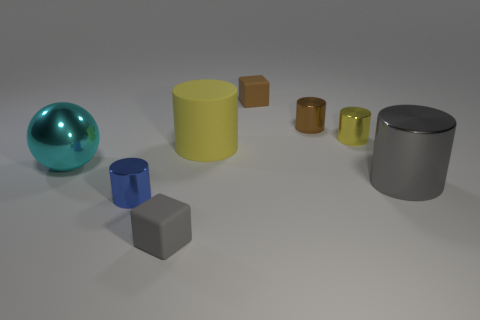Subtract all green balls. How many yellow cylinders are left? 2 Subtract all gray cylinders. How many cylinders are left? 4 Add 1 small brown cylinders. How many objects exist? 9 Subtract all blue cylinders. How many cylinders are left? 4 Subtract all cylinders. How many objects are left? 3 Subtract all blue cylinders. Subtract all green spheres. How many cylinders are left? 4 Add 5 large gray metal cylinders. How many large gray metal cylinders exist? 6 Subtract 1 blue cylinders. How many objects are left? 7 Subtract all big red balls. Subtract all small brown things. How many objects are left? 6 Add 3 brown things. How many brown things are left? 5 